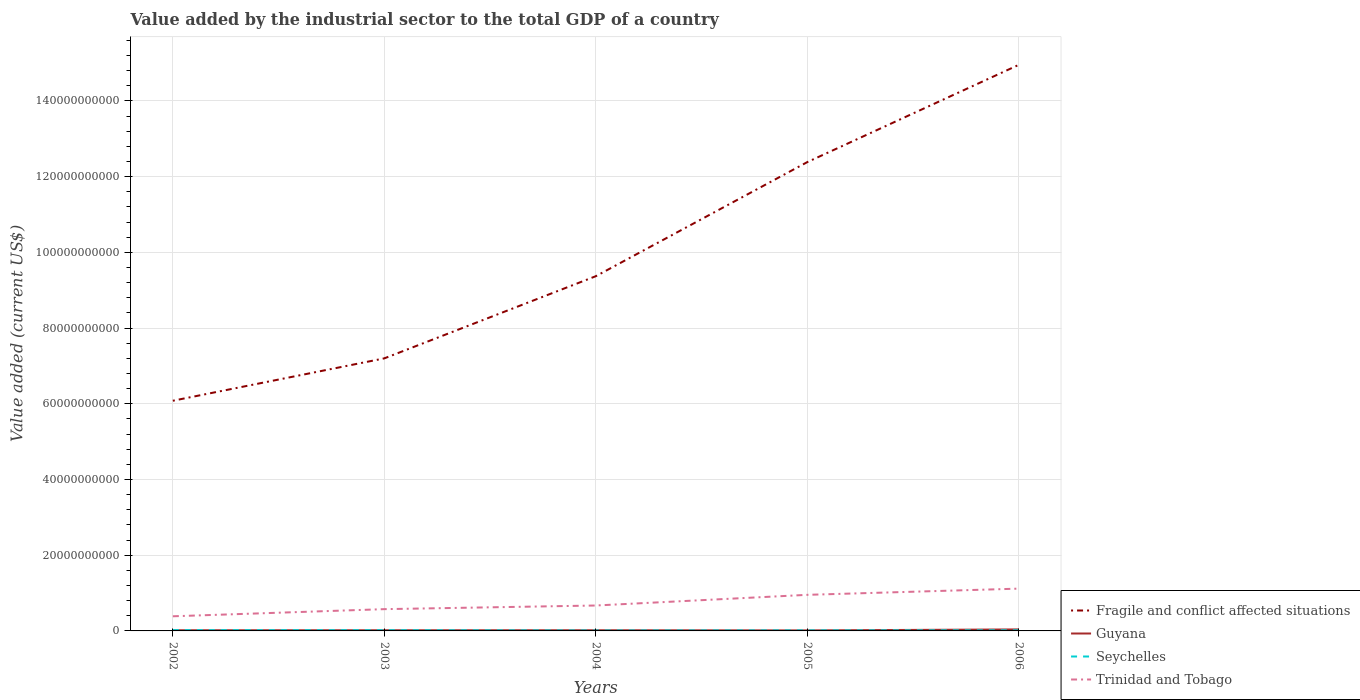Does the line corresponding to Seychelles intersect with the line corresponding to Fragile and conflict affected situations?
Ensure brevity in your answer.  No. Is the number of lines equal to the number of legend labels?
Make the answer very short. Yes. Across all years, what is the maximum value added by the industrial sector to the total GDP in Guyana?
Give a very brief answer. 1.38e+08. In which year was the value added by the industrial sector to the total GDP in Fragile and conflict affected situations maximum?
Your answer should be very brief. 2002. What is the total value added by the industrial sector to the total GDP in Trinidad and Tobago in the graph?
Ensure brevity in your answer.  -9.61e+08. What is the difference between the highest and the second highest value added by the industrial sector to the total GDP in Fragile and conflict affected situations?
Your response must be concise. 8.87e+1. What is the difference between the highest and the lowest value added by the industrial sector to the total GDP in Seychelles?
Make the answer very short. 2. Is the value added by the industrial sector to the total GDP in Guyana strictly greater than the value added by the industrial sector to the total GDP in Fragile and conflict affected situations over the years?
Provide a short and direct response. Yes. Where does the legend appear in the graph?
Your answer should be very brief. Bottom right. How many legend labels are there?
Offer a terse response. 4. How are the legend labels stacked?
Ensure brevity in your answer.  Vertical. What is the title of the graph?
Ensure brevity in your answer.  Value added by the industrial sector to the total GDP of a country. What is the label or title of the Y-axis?
Make the answer very short. Value added (current US$). What is the Value added (current US$) of Fragile and conflict affected situations in 2002?
Your answer should be very brief. 6.08e+1. What is the Value added (current US$) in Guyana in 2002?
Provide a succinct answer. 1.77e+08. What is the Value added (current US$) of Seychelles in 2002?
Your answer should be compact. 2.11e+08. What is the Value added (current US$) of Trinidad and Tobago in 2002?
Keep it short and to the point. 3.87e+09. What is the Value added (current US$) in Fragile and conflict affected situations in 2003?
Your answer should be compact. 7.20e+1. What is the Value added (current US$) of Guyana in 2003?
Offer a very short reply. 1.73e+08. What is the Value added (current US$) in Seychelles in 2003?
Make the answer very short. 1.93e+08. What is the Value added (current US$) of Trinidad and Tobago in 2003?
Offer a terse response. 5.75e+09. What is the Value added (current US$) of Fragile and conflict affected situations in 2004?
Ensure brevity in your answer.  9.37e+1. What is the Value added (current US$) of Guyana in 2004?
Give a very brief answer. 1.78e+08. What is the Value added (current US$) in Seychelles in 2004?
Offer a terse response. 1.24e+08. What is the Value added (current US$) of Trinidad and Tobago in 2004?
Ensure brevity in your answer.  6.71e+09. What is the Value added (current US$) in Fragile and conflict affected situations in 2005?
Give a very brief answer. 1.24e+11. What is the Value added (current US$) in Guyana in 2005?
Give a very brief answer. 1.38e+08. What is the Value added (current US$) of Seychelles in 2005?
Your answer should be compact. 1.51e+08. What is the Value added (current US$) of Trinidad and Tobago in 2005?
Make the answer very short. 9.53e+09. What is the Value added (current US$) of Fragile and conflict affected situations in 2006?
Your answer should be compact. 1.50e+11. What is the Value added (current US$) in Guyana in 2006?
Your answer should be very brief. 3.94e+08. What is the Value added (current US$) in Seychelles in 2006?
Your answer should be compact. 1.65e+08. What is the Value added (current US$) of Trinidad and Tobago in 2006?
Give a very brief answer. 1.12e+1. Across all years, what is the maximum Value added (current US$) of Fragile and conflict affected situations?
Ensure brevity in your answer.  1.50e+11. Across all years, what is the maximum Value added (current US$) in Guyana?
Offer a terse response. 3.94e+08. Across all years, what is the maximum Value added (current US$) in Seychelles?
Offer a very short reply. 2.11e+08. Across all years, what is the maximum Value added (current US$) in Trinidad and Tobago?
Offer a very short reply. 1.12e+1. Across all years, what is the minimum Value added (current US$) of Fragile and conflict affected situations?
Your response must be concise. 6.08e+1. Across all years, what is the minimum Value added (current US$) of Guyana?
Your response must be concise. 1.38e+08. Across all years, what is the minimum Value added (current US$) of Seychelles?
Offer a terse response. 1.24e+08. Across all years, what is the minimum Value added (current US$) in Trinidad and Tobago?
Your answer should be very brief. 3.87e+09. What is the total Value added (current US$) of Fragile and conflict affected situations in the graph?
Offer a terse response. 5.00e+11. What is the total Value added (current US$) of Guyana in the graph?
Keep it short and to the point. 1.06e+09. What is the total Value added (current US$) of Seychelles in the graph?
Ensure brevity in your answer.  8.44e+08. What is the total Value added (current US$) of Trinidad and Tobago in the graph?
Make the answer very short. 3.70e+1. What is the difference between the Value added (current US$) of Fragile and conflict affected situations in 2002 and that in 2003?
Give a very brief answer. -1.12e+1. What is the difference between the Value added (current US$) of Guyana in 2002 and that in 2003?
Your answer should be very brief. 3.67e+06. What is the difference between the Value added (current US$) in Seychelles in 2002 and that in 2003?
Ensure brevity in your answer.  1.77e+07. What is the difference between the Value added (current US$) of Trinidad and Tobago in 2002 and that in 2003?
Your response must be concise. -1.89e+09. What is the difference between the Value added (current US$) of Fragile and conflict affected situations in 2002 and that in 2004?
Provide a succinct answer. -3.29e+1. What is the difference between the Value added (current US$) in Guyana in 2002 and that in 2004?
Offer a very short reply. -9.74e+05. What is the difference between the Value added (current US$) in Seychelles in 2002 and that in 2004?
Make the answer very short. 8.70e+07. What is the difference between the Value added (current US$) in Trinidad and Tobago in 2002 and that in 2004?
Provide a short and direct response. -2.85e+09. What is the difference between the Value added (current US$) of Fragile and conflict affected situations in 2002 and that in 2005?
Your answer should be compact. -6.30e+1. What is the difference between the Value added (current US$) of Guyana in 2002 and that in 2005?
Provide a succinct answer. 3.90e+07. What is the difference between the Value added (current US$) of Seychelles in 2002 and that in 2005?
Give a very brief answer. 6.04e+07. What is the difference between the Value added (current US$) in Trinidad and Tobago in 2002 and that in 2005?
Your answer should be compact. -5.67e+09. What is the difference between the Value added (current US$) of Fragile and conflict affected situations in 2002 and that in 2006?
Your response must be concise. -8.87e+1. What is the difference between the Value added (current US$) in Guyana in 2002 and that in 2006?
Ensure brevity in your answer.  -2.18e+08. What is the difference between the Value added (current US$) in Seychelles in 2002 and that in 2006?
Provide a succinct answer. 4.61e+07. What is the difference between the Value added (current US$) in Trinidad and Tobago in 2002 and that in 2006?
Keep it short and to the point. -7.31e+09. What is the difference between the Value added (current US$) in Fragile and conflict affected situations in 2003 and that in 2004?
Your answer should be very brief. -2.17e+1. What is the difference between the Value added (current US$) of Guyana in 2003 and that in 2004?
Keep it short and to the point. -4.64e+06. What is the difference between the Value added (current US$) in Seychelles in 2003 and that in 2004?
Your response must be concise. 6.92e+07. What is the difference between the Value added (current US$) in Trinidad and Tobago in 2003 and that in 2004?
Provide a short and direct response. -9.61e+08. What is the difference between the Value added (current US$) in Fragile and conflict affected situations in 2003 and that in 2005?
Keep it short and to the point. -5.18e+1. What is the difference between the Value added (current US$) of Guyana in 2003 and that in 2005?
Your response must be concise. 3.54e+07. What is the difference between the Value added (current US$) in Seychelles in 2003 and that in 2005?
Offer a terse response. 4.27e+07. What is the difference between the Value added (current US$) in Trinidad and Tobago in 2003 and that in 2005?
Offer a very short reply. -3.78e+09. What is the difference between the Value added (current US$) of Fragile and conflict affected situations in 2003 and that in 2006?
Your response must be concise. -7.75e+1. What is the difference between the Value added (current US$) in Guyana in 2003 and that in 2006?
Provide a succinct answer. -2.21e+08. What is the difference between the Value added (current US$) in Seychelles in 2003 and that in 2006?
Provide a succinct answer. 2.83e+07. What is the difference between the Value added (current US$) in Trinidad and Tobago in 2003 and that in 2006?
Your answer should be compact. -5.42e+09. What is the difference between the Value added (current US$) of Fragile and conflict affected situations in 2004 and that in 2005?
Your response must be concise. -3.01e+1. What is the difference between the Value added (current US$) of Guyana in 2004 and that in 2005?
Keep it short and to the point. 4.00e+07. What is the difference between the Value added (current US$) in Seychelles in 2004 and that in 2005?
Keep it short and to the point. -2.65e+07. What is the difference between the Value added (current US$) in Trinidad and Tobago in 2004 and that in 2005?
Your answer should be very brief. -2.82e+09. What is the difference between the Value added (current US$) in Fragile and conflict affected situations in 2004 and that in 2006?
Your answer should be very brief. -5.58e+1. What is the difference between the Value added (current US$) in Guyana in 2004 and that in 2006?
Offer a very short reply. -2.17e+08. What is the difference between the Value added (current US$) of Seychelles in 2004 and that in 2006?
Provide a succinct answer. -4.09e+07. What is the difference between the Value added (current US$) of Trinidad and Tobago in 2004 and that in 2006?
Ensure brevity in your answer.  -4.46e+09. What is the difference between the Value added (current US$) in Fragile and conflict affected situations in 2005 and that in 2006?
Provide a succinct answer. -2.57e+1. What is the difference between the Value added (current US$) in Guyana in 2005 and that in 2006?
Provide a succinct answer. -2.57e+08. What is the difference between the Value added (current US$) in Seychelles in 2005 and that in 2006?
Provide a short and direct response. -1.43e+07. What is the difference between the Value added (current US$) of Trinidad and Tobago in 2005 and that in 2006?
Provide a short and direct response. -1.64e+09. What is the difference between the Value added (current US$) of Fragile and conflict affected situations in 2002 and the Value added (current US$) of Guyana in 2003?
Provide a short and direct response. 6.06e+1. What is the difference between the Value added (current US$) in Fragile and conflict affected situations in 2002 and the Value added (current US$) in Seychelles in 2003?
Provide a succinct answer. 6.06e+1. What is the difference between the Value added (current US$) of Fragile and conflict affected situations in 2002 and the Value added (current US$) of Trinidad and Tobago in 2003?
Keep it short and to the point. 5.50e+1. What is the difference between the Value added (current US$) in Guyana in 2002 and the Value added (current US$) in Seychelles in 2003?
Offer a terse response. -1.68e+07. What is the difference between the Value added (current US$) of Guyana in 2002 and the Value added (current US$) of Trinidad and Tobago in 2003?
Your response must be concise. -5.58e+09. What is the difference between the Value added (current US$) in Seychelles in 2002 and the Value added (current US$) in Trinidad and Tobago in 2003?
Provide a succinct answer. -5.54e+09. What is the difference between the Value added (current US$) of Fragile and conflict affected situations in 2002 and the Value added (current US$) of Guyana in 2004?
Make the answer very short. 6.06e+1. What is the difference between the Value added (current US$) in Fragile and conflict affected situations in 2002 and the Value added (current US$) in Seychelles in 2004?
Your answer should be very brief. 6.07e+1. What is the difference between the Value added (current US$) of Fragile and conflict affected situations in 2002 and the Value added (current US$) of Trinidad and Tobago in 2004?
Your response must be concise. 5.41e+1. What is the difference between the Value added (current US$) of Guyana in 2002 and the Value added (current US$) of Seychelles in 2004?
Your response must be concise. 5.24e+07. What is the difference between the Value added (current US$) in Guyana in 2002 and the Value added (current US$) in Trinidad and Tobago in 2004?
Your response must be concise. -6.54e+09. What is the difference between the Value added (current US$) of Seychelles in 2002 and the Value added (current US$) of Trinidad and Tobago in 2004?
Ensure brevity in your answer.  -6.50e+09. What is the difference between the Value added (current US$) in Fragile and conflict affected situations in 2002 and the Value added (current US$) in Guyana in 2005?
Your answer should be very brief. 6.07e+1. What is the difference between the Value added (current US$) in Fragile and conflict affected situations in 2002 and the Value added (current US$) in Seychelles in 2005?
Make the answer very short. 6.06e+1. What is the difference between the Value added (current US$) in Fragile and conflict affected situations in 2002 and the Value added (current US$) in Trinidad and Tobago in 2005?
Provide a short and direct response. 5.13e+1. What is the difference between the Value added (current US$) in Guyana in 2002 and the Value added (current US$) in Seychelles in 2005?
Give a very brief answer. 2.58e+07. What is the difference between the Value added (current US$) in Guyana in 2002 and the Value added (current US$) in Trinidad and Tobago in 2005?
Offer a very short reply. -9.36e+09. What is the difference between the Value added (current US$) in Seychelles in 2002 and the Value added (current US$) in Trinidad and Tobago in 2005?
Ensure brevity in your answer.  -9.32e+09. What is the difference between the Value added (current US$) in Fragile and conflict affected situations in 2002 and the Value added (current US$) in Guyana in 2006?
Provide a short and direct response. 6.04e+1. What is the difference between the Value added (current US$) of Fragile and conflict affected situations in 2002 and the Value added (current US$) of Seychelles in 2006?
Offer a very short reply. 6.06e+1. What is the difference between the Value added (current US$) in Fragile and conflict affected situations in 2002 and the Value added (current US$) in Trinidad and Tobago in 2006?
Make the answer very short. 4.96e+1. What is the difference between the Value added (current US$) in Guyana in 2002 and the Value added (current US$) in Seychelles in 2006?
Offer a very short reply. 1.15e+07. What is the difference between the Value added (current US$) of Guyana in 2002 and the Value added (current US$) of Trinidad and Tobago in 2006?
Offer a terse response. -1.10e+1. What is the difference between the Value added (current US$) in Seychelles in 2002 and the Value added (current US$) in Trinidad and Tobago in 2006?
Provide a succinct answer. -1.10e+1. What is the difference between the Value added (current US$) in Fragile and conflict affected situations in 2003 and the Value added (current US$) in Guyana in 2004?
Your response must be concise. 7.18e+1. What is the difference between the Value added (current US$) in Fragile and conflict affected situations in 2003 and the Value added (current US$) in Seychelles in 2004?
Keep it short and to the point. 7.19e+1. What is the difference between the Value added (current US$) in Fragile and conflict affected situations in 2003 and the Value added (current US$) in Trinidad and Tobago in 2004?
Offer a terse response. 6.53e+1. What is the difference between the Value added (current US$) of Guyana in 2003 and the Value added (current US$) of Seychelles in 2004?
Provide a succinct answer. 4.87e+07. What is the difference between the Value added (current US$) of Guyana in 2003 and the Value added (current US$) of Trinidad and Tobago in 2004?
Your answer should be very brief. -6.54e+09. What is the difference between the Value added (current US$) of Seychelles in 2003 and the Value added (current US$) of Trinidad and Tobago in 2004?
Your answer should be very brief. -6.52e+09. What is the difference between the Value added (current US$) of Fragile and conflict affected situations in 2003 and the Value added (current US$) of Guyana in 2005?
Offer a terse response. 7.19e+1. What is the difference between the Value added (current US$) in Fragile and conflict affected situations in 2003 and the Value added (current US$) in Seychelles in 2005?
Make the answer very short. 7.18e+1. What is the difference between the Value added (current US$) in Fragile and conflict affected situations in 2003 and the Value added (current US$) in Trinidad and Tobago in 2005?
Ensure brevity in your answer.  6.25e+1. What is the difference between the Value added (current US$) of Guyana in 2003 and the Value added (current US$) of Seychelles in 2005?
Provide a short and direct response. 2.22e+07. What is the difference between the Value added (current US$) in Guyana in 2003 and the Value added (current US$) in Trinidad and Tobago in 2005?
Offer a terse response. -9.36e+09. What is the difference between the Value added (current US$) of Seychelles in 2003 and the Value added (current US$) of Trinidad and Tobago in 2005?
Your answer should be compact. -9.34e+09. What is the difference between the Value added (current US$) of Fragile and conflict affected situations in 2003 and the Value added (current US$) of Guyana in 2006?
Keep it short and to the point. 7.16e+1. What is the difference between the Value added (current US$) of Fragile and conflict affected situations in 2003 and the Value added (current US$) of Seychelles in 2006?
Offer a terse response. 7.18e+1. What is the difference between the Value added (current US$) in Fragile and conflict affected situations in 2003 and the Value added (current US$) in Trinidad and Tobago in 2006?
Give a very brief answer. 6.08e+1. What is the difference between the Value added (current US$) of Guyana in 2003 and the Value added (current US$) of Seychelles in 2006?
Your response must be concise. 7.83e+06. What is the difference between the Value added (current US$) in Guyana in 2003 and the Value added (current US$) in Trinidad and Tobago in 2006?
Make the answer very short. -1.10e+1. What is the difference between the Value added (current US$) of Seychelles in 2003 and the Value added (current US$) of Trinidad and Tobago in 2006?
Your answer should be compact. -1.10e+1. What is the difference between the Value added (current US$) in Fragile and conflict affected situations in 2004 and the Value added (current US$) in Guyana in 2005?
Your answer should be compact. 9.36e+1. What is the difference between the Value added (current US$) of Fragile and conflict affected situations in 2004 and the Value added (current US$) of Seychelles in 2005?
Your answer should be compact. 9.35e+1. What is the difference between the Value added (current US$) of Fragile and conflict affected situations in 2004 and the Value added (current US$) of Trinidad and Tobago in 2005?
Offer a terse response. 8.42e+1. What is the difference between the Value added (current US$) in Guyana in 2004 and the Value added (current US$) in Seychelles in 2005?
Keep it short and to the point. 2.68e+07. What is the difference between the Value added (current US$) of Guyana in 2004 and the Value added (current US$) of Trinidad and Tobago in 2005?
Give a very brief answer. -9.36e+09. What is the difference between the Value added (current US$) of Seychelles in 2004 and the Value added (current US$) of Trinidad and Tobago in 2005?
Your response must be concise. -9.41e+09. What is the difference between the Value added (current US$) in Fragile and conflict affected situations in 2004 and the Value added (current US$) in Guyana in 2006?
Your answer should be very brief. 9.33e+1. What is the difference between the Value added (current US$) in Fragile and conflict affected situations in 2004 and the Value added (current US$) in Seychelles in 2006?
Provide a succinct answer. 9.35e+1. What is the difference between the Value added (current US$) in Fragile and conflict affected situations in 2004 and the Value added (current US$) in Trinidad and Tobago in 2006?
Offer a terse response. 8.25e+1. What is the difference between the Value added (current US$) in Guyana in 2004 and the Value added (current US$) in Seychelles in 2006?
Give a very brief answer. 1.25e+07. What is the difference between the Value added (current US$) in Guyana in 2004 and the Value added (current US$) in Trinidad and Tobago in 2006?
Your answer should be very brief. -1.10e+1. What is the difference between the Value added (current US$) of Seychelles in 2004 and the Value added (current US$) of Trinidad and Tobago in 2006?
Your response must be concise. -1.10e+1. What is the difference between the Value added (current US$) of Fragile and conflict affected situations in 2005 and the Value added (current US$) of Guyana in 2006?
Make the answer very short. 1.23e+11. What is the difference between the Value added (current US$) in Fragile and conflict affected situations in 2005 and the Value added (current US$) in Seychelles in 2006?
Provide a short and direct response. 1.24e+11. What is the difference between the Value added (current US$) in Fragile and conflict affected situations in 2005 and the Value added (current US$) in Trinidad and Tobago in 2006?
Give a very brief answer. 1.13e+11. What is the difference between the Value added (current US$) in Guyana in 2005 and the Value added (current US$) in Seychelles in 2006?
Ensure brevity in your answer.  -2.75e+07. What is the difference between the Value added (current US$) in Guyana in 2005 and the Value added (current US$) in Trinidad and Tobago in 2006?
Your answer should be very brief. -1.10e+1. What is the difference between the Value added (current US$) in Seychelles in 2005 and the Value added (current US$) in Trinidad and Tobago in 2006?
Make the answer very short. -1.10e+1. What is the average Value added (current US$) in Fragile and conflict affected situations per year?
Your response must be concise. 1.00e+11. What is the average Value added (current US$) in Guyana per year?
Your response must be concise. 2.12e+08. What is the average Value added (current US$) of Seychelles per year?
Your response must be concise. 1.69e+08. What is the average Value added (current US$) in Trinidad and Tobago per year?
Provide a short and direct response. 7.41e+09. In the year 2002, what is the difference between the Value added (current US$) of Fragile and conflict affected situations and Value added (current US$) of Guyana?
Your response must be concise. 6.06e+1. In the year 2002, what is the difference between the Value added (current US$) of Fragile and conflict affected situations and Value added (current US$) of Seychelles?
Keep it short and to the point. 6.06e+1. In the year 2002, what is the difference between the Value added (current US$) of Fragile and conflict affected situations and Value added (current US$) of Trinidad and Tobago?
Ensure brevity in your answer.  5.69e+1. In the year 2002, what is the difference between the Value added (current US$) of Guyana and Value added (current US$) of Seychelles?
Give a very brief answer. -3.46e+07. In the year 2002, what is the difference between the Value added (current US$) of Guyana and Value added (current US$) of Trinidad and Tobago?
Keep it short and to the point. -3.69e+09. In the year 2002, what is the difference between the Value added (current US$) of Seychelles and Value added (current US$) of Trinidad and Tobago?
Provide a short and direct response. -3.65e+09. In the year 2003, what is the difference between the Value added (current US$) of Fragile and conflict affected situations and Value added (current US$) of Guyana?
Provide a succinct answer. 7.18e+1. In the year 2003, what is the difference between the Value added (current US$) of Fragile and conflict affected situations and Value added (current US$) of Seychelles?
Ensure brevity in your answer.  7.18e+1. In the year 2003, what is the difference between the Value added (current US$) in Fragile and conflict affected situations and Value added (current US$) in Trinidad and Tobago?
Provide a short and direct response. 6.62e+1. In the year 2003, what is the difference between the Value added (current US$) of Guyana and Value added (current US$) of Seychelles?
Provide a short and direct response. -2.05e+07. In the year 2003, what is the difference between the Value added (current US$) of Guyana and Value added (current US$) of Trinidad and Tobago?
Give a very brief answer. -5.58e+09. In the year 2003, what is the difference between the Value added (current US$) in Seychelles and Value added (current US$) in Trinidad and Tobago?
Give a very brief answer. -5.56e+09. In the year 2004, what is the difference between the Value added (current US$) of Fragile and conflict affected situations and Value added (current US$) of Guyana?
Give a very brief answer. 9.35e+1. In the year 2004, what is the difference between the Value added (current US$) in Fragile and conflict affected situations and Value added (current US$) in Seychelles?
Keep it short and to the point. 9.36e+1. In the year 2004, what is the difference between the Value added (current US$) in Fragile and conflict affected situations and Value added (current US$) in Trinidad and Tobago?
Your response must be concise. 8.70e+1. In the year 2004, what is the difference between the Value added (current US$) of Guyana and Value added (current US$) of Seychelles?
Provide a short and direct response. 5.34e+07. In the year 2004, what is the difference between the Value added (current US$) in Guyana and Value added (current US$) in Trinidad and Tobago?
Your answer should be very brief. -6.54e+09. In the year 2004, what is the difference between the Value added (current US$) in Seychelles and Value added (current US$) in Trinidad and Tobago?
Give a very brief answer. -6.59e+09. In the year 2005, what is the difference between the Value added (current US$) of Fragile and conflict affected situations and Value added (current US$) of Guyana?
Your answer should be compact. 1.24e+11. In the year 2005, what is the difference between the Value added (current US$) of Fragile and conflict affected situations and Value added (current US$) of Seychelles?
Your answer should be compact. 1.24e+11. In the year 2005, what is the difference between the Value added (current US$) of Fragile and conflict affected situations and Value added (current US$) of Trinidad and Tobago?
Ensure brevity in your answer.  1.14e+11. In the year 2005, what is the difference between the Value added (current US$) of Guyana and Value added (current US$) of Seychelles?
Ensure brevity in your answer.  -1.32e+07. In the year 2005, what is the difference between the Value added (current US$) of Guyana and Value added (current US$) of Trinidad and Tobago?
Provide a short and direct response. -9.40e+09. In the year 2005, what is the difference between the Value added (current US$) of Seychelles and Value added (current US$) of Trinidad and Tobago?
Ensure brevity in your answer.  -9.38e+09. In the year 2006, what is the difference between the Value added (current US$) in Fragile and conflict affected situations and Value added (current US$) in Guyana?
Your answer should be compact. 1.49e+11. In the year 2006, what is the difference between the Value added (current US$) of Fragile and conflict affected situations and Value added (current US$) of Seychelles?
Give a very brief answer. 1.49e+11. In the year 2006, what is the difference between the Value added (current US$) in Fragile and conflict affected situations and Value added (current US$) in Trinidad and Tobago?
Give a very brief answer. 1.38e+11. In the year 2006, what is the difference between the Value added (current US$) of Guyana and Value added (current US$) of Seychelles?
Keep it short and to the point. 2.29e+08. In the year 2006, what is the difference between the Value added (current US$) of Guyana and Value added (current US$) of Trinidad and Tobago?
Provide a short and direct response. -1.08e+1. In the year 2006, what is the difference between the Value added (current US$) of Seychelles and Value added (current US$) of Trinidad and Tobago?
Your answer should be compact. -1.10e+1. What is the ratio of the Value added (current US$) of Fragile and conflict affected situations in 2002 to that in 2003?
Your response must be concise. 0.84. What is the ratio of the Value added (current US$) in Guyana in 2002 to that in 2003?
Your answer should be compact. 1.02. What is the ratio of the Value added (current US$) in Seychelles in 2002 to that in 2003?
Your answer should be very brief. 1.09. What is the ratio of the Value added (current US$) in Trinidad and Tobago in 2002 to that in 2003?
Provide a short and direct response. 0.67. What is the ratio of the Value added (current US$) in Fragile and conflict affected situations in 2002 to that in 2004?
Ensure brevity in your answer.  0.65. What is the ratio of the Value added (current US$) of Seychelles in 2002 to that in 2004?
Provide a succinct answer. 1.7. What is the ratio of the Value added (current US$) in Trinidad and Tobago in 2002 to that in 2004?
Make the answer very short. 0.58. What is the ratio of the Value added (current US$) in Fragile and conflict affected situations in 2002 to that in 2005?
Provide a succinct answer. 0.49. What is the ratio of the Value added (current US$) in Guyana in 2002 to that in 2005?
Your answer should be compact. 1.28. What is the ratio of the Value added (current US$) in Seychelles in 2002 to that in 2005?
Provide a succinct answer. 1.4. What is the ratio of the Value added (current US$) in Trinidad and Tobago in 2002 to that in 2005?
Your response must be concise. 0.41. What is the ratio of the Value added (current US$) of Fragile and conflict affected situations in 2002 to that in 2006?
Make the answer very short. 0.41. What is the ratio of the Value added (current US$) in Guyana in 2002 to that in 2006?
Provide a short and direct response. 0.45. What is the ratio of the Value added (current US$) in Seychelles in 2002 to that in 2006?
Offer a terse response. 1.28. What is the ratio of the Value added (current US$) of Trinidad and Tobago in 2002 to that in 2006?
Offer a very short reply. 0.35. What is the ratio of the Value added (current US$) of Fragile and conflict affected situations in 2003 to that in 2004?
Give a very brief answer. 0.77. What is the ratio of the Value added (current US$) in Guyana in 2003 to that in 2004?
Offer a terse response. 0.97. What is the ratio of the Value added (current US$) of Seychelles in 2003 to that in 2004?
Make the answer very short. 1.56. What is the ratio of the Value added (current US$) in Trinidad and Tobago in 2003 to that in 2004?
Ensure brevity in your answer.  0.86. What is the ratio of the Value added (current US$) in Fragile and conflict affected situations in 2003 to that in 2005?
Give a very brief answer. 0.58. What is the ratio of the Value added (current US$) in Guyana in 2003 to that in 2005?
Offer a terse response. 1.26. What is the ratio of the Value added (current US$) in Seychelles in 2003 to that in 2005?
Offer a very short reply. 1.28. What is the ratio of the Value added (current US$) in Trinidad and Tobago in 2003 to that in 2005?
Your answer should be very brief. 0.6. What is the ratio of the Value added (current US$) of Fragile and conflict affected situations in 2003 to that in 2006?
Ensure brevity in your answer.  0.48. What is the ratio of the Value added (current US$) of Guyana in 2003 to that in 2006?
Your response must be concise. 0.44. What is the ratio of the Value added (current US$) of Seychelles in 2003 to that in 2006?
Your response must be concise. 1.17. What is the ratio of the Value added (current US$) of Trinidad and Tobago in 2003 to that in 2006?
Offer a terse response. 0.51. What is the ratio of the Value added (current US$) of Fragile and conflict affected situations in 2004 to that in 2005?
Provide a succinct answer. 0.76. What is the ratio of the Value added (current US$) of Guyana in 2004 to that in 2005?
Provide a succinct answer. 1.29. What is the ratio of the Value added (current US$) in Seychelles in 2004 to that in 2005?
Offer a terse response. 0.82. What is the ratio of the Value added (current US$) in Trinidad and Tobago in 2004 to that in 2005?
Provide a short and direct response. 0.7. What is the ratio of the Value added (current US$) of Fragile and conflict affected situations in 2004 to that in 2006?
Ensure brevity in your answer.  0.63. What is the ratio of the Value added (current US$) in Guyana in 2004 to that in 2006?
Ensure brevity in your answer.  0.45. What is the ratio of the Value added (current US$) of Seychelles in 2004 to that in 2006?
Make the answer very short. 0.75. What is the ratio of the Value added (current US$) in Trinidad and Tobago in 2004 to that in 2006?
Ensure brevity in your answer.  0.6. What is the ratio of the Value added (current US$) in Fragile and conflict affected situations in 2005 to that in 2006?
Offer a very short reply. 0.83. What is the ratio of the Value added (current US$) of Guyana in 2005 to that in 2006?
Provide a short and direct response. 0.35. What is the ratio of the Value added (current US$) in Seychelles in 2005 to that in 2006?
Provide a succinct answer. 0.91. What is the ratio of the Value added (current US$) of Trinidad and Tobago in 2005 to that in 2006?
Provide a succinct answer. 0.85. What is the difference between the highest and the second highest Value added (current US$) in Fragile and conflict affected situations?
Give a very brief answer. 2.57e+1. What is the difference between the highest and the second highest Value added (current US$) of Guyana?
Make the answer very short. 2.17e+08. What is the difference between the highest and the second highest Value added (current US$) in Seychelles?
Give a very brief answer. 1.77e+07. What is the difference between the highest and the second highest Value added (current US$) of Trinidad and Tobago?
Make the answer very short. 1.64e+09. What is the difference between the highest and the lowest Value added (current US$) in Fragile and conflict affected situations?
Provide a short and direct response. 8.87e+1. What is the difference between the highest and the lowest Value added (current US$) of Guyana?
Offer a terse response. 2.57e+08. What is the difference between the highest and the lowest Value added (current US$) in Seychelles?
Keep it short and to the point. 8.70e+07. What is the difference between the highest and the lowest Value added (current US$) in Trinidad and Tobago?
Provide a succinct answer. 7.31e+09. 